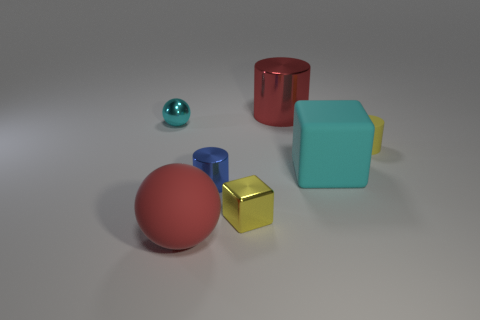Add 2 blue metal objects. How many objects exist? 9 Subtract all spheres. How many objects are left? 5 Add 3 small matte objects. How many small matte objects are left? 4 Add 1 small brown rubber cylinders. How many small brown rubber cylinders exist? 1 Subtract 0 brown spheres. How many objects are left? 7 Subtract all tiny cyan metallic spheres. Subtract all balls. How many objects are left? 4 